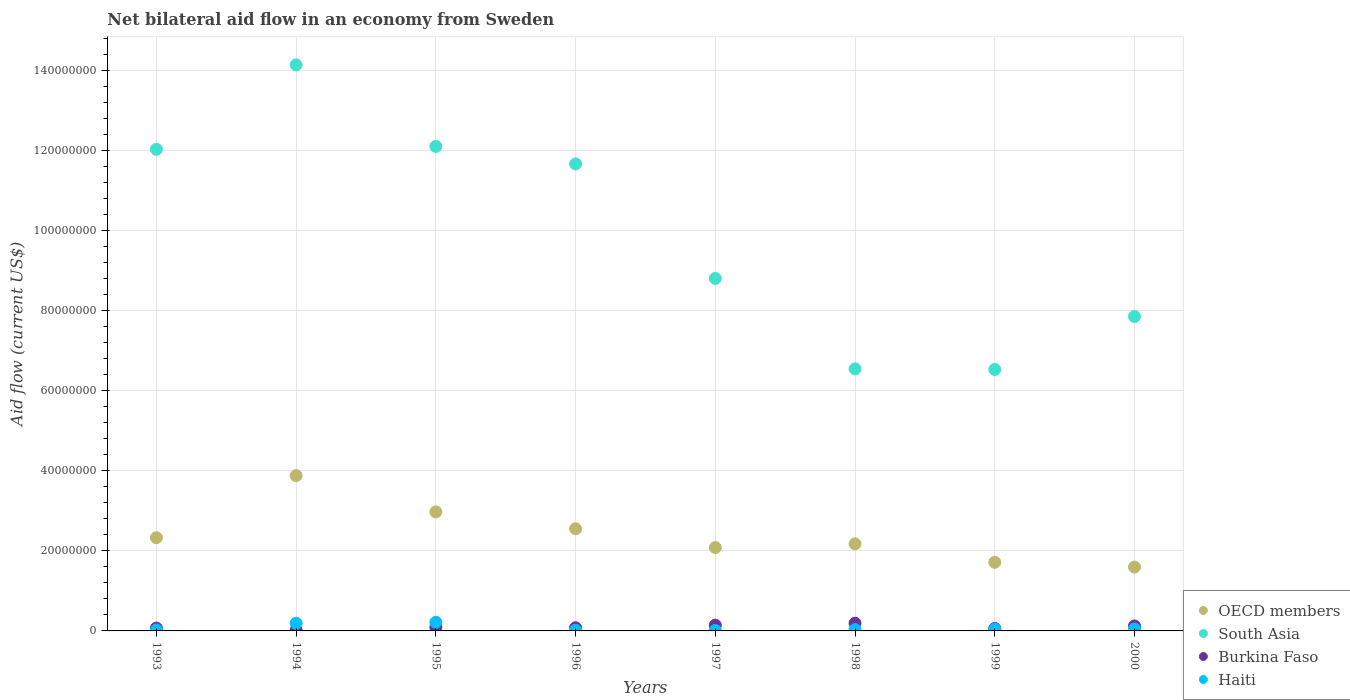How many different coloured dotlines are there?
Your answer should be very brief. 4. What is the net bilateral aid flow in South Asia in 1996?
Your answer should be compact. 1.17e+08. Across all years, what is the maximum net bilateral aid flow in Haiti?
Give a very brief answer. 2.16e+06. Across all years, what is the minimum net bilateral aid flow in Haiti?
Your response must be concise. 1.20e+05. In which year was the net bilateral aid flow in South Asia maximum?
Your answer should be very brief. 1994. What is the total net bilateral aid flow in OECD members in the graph?
Give a very brief answer. 1.93e+08. What is the difference between the net bilateral aid flow in Burkina Faso in 1993 and that in 1994?
Keep it short and to the point. 5.30e+05. What is the difference between the net bilateral aid flow in OECD members in 1998 and the net bilateral aid flow in South Asia in 1994?
Keep it short and to the point. -1.20e+08. What is the average net bilateral aid flow in Burkina Faso per year?
Give a very brief answer. 9.79e+05. In the year 1999, what is the difference between the net bilateral aid flow in South Asia and net bilateral aid flow in Burkina Faso?
Your answer should be compact. 6.47e+07. What is the ratio of the net bilateral aid flow in OECD members in 1998 to that in 2000?
Provide a succinct answer. 1.36. What is the difference between the highest and the second highest net bilateral aid flow in South Asia?
Offer a terse response. 2.04e+07. What is the difference between the highest and the lowest net bilateral aid flow in Burkina Faso?
Give a very brief answer. 1.75e+06. Is the sum of the net bilateral aid flow in OECD members in 1993 and 1996 greater than the maximum net bilateral aid flow in Burkina Faso across all years?
Your response must be concise. Yes. Is it the case that in every year, the sum of the net bilateral aid flow in South Asia and net bilateral aid flow in Burkina Faso  is greater than the sum of net bilateral aid flow in Haiti and net bilateral aid flow in OECD members?
Offer a terse response. Yes. Is the net bilateral aid flow in South Asia strictly greater than the net bilateral aid flow in Burkina Faso over the years?
Keep it short and to the point. Yes. How many dotlines are there?
Give a very brief answer. 4. What is the difference between two consecutive major ticks on the Y-axis?
Provide a succinct answer. 2.00e+07. Does the graph contain grids?
Give a very brief answer. Yes. Where does the legend appear in the graph?
Your response must be concise. Bottom right. How are the legend labels stacked?
Provide a short and direct response. Vertical. What is the title of the graph?
Your answer should be compact. Net bilateral aid flow in an economy from Sweden. Does "Brazil" appear as one of the legend labels in the graph?
Give a very brief answer. No. What is the Aid flow (current US$) of OECD members in 1993?
Your answer should be very brief. 2.33e+07. What is the Aid flow (current US$) of South Asia in 1993?
Ensure brevity in your answer.  1.20e+08. What is the Aid flow (current US$) in Burkina Faso in 1993?
Your answer should be very brief. 7.10e+05. What is the Aid flow (current US$) of OECD members in 1994?
Give a very brief answer. 3.88e+07. What is the Aid flow (current US$) in South Asia in 1994?
Make the answer very short. 1.41e+08. What is the Aid flow (current US$) in Haiti in 1994?
Make the answer very short. 1.90e+06. What is the Aid flow (current US$) in OECD members in 1995?
Give a very brief answer. 2.97e+07. What is the Aid flow (current US$) in South Asia in 1995?
Provide a short and direct response. 1.21e+08. What is the Aid flow (current US$) of Burkina Faso in 1995?
Your answer should be very brief. 9.10e+05. What is the Aid flow (current US$) in Haiti in 1995?
Your answer should be very brief. 2.16e+06. What is the Aid flow (current US$) of OECD members in 1996?
Your response must be concise. 2.55e+07. What is the Aid flow (current US$) of South Asia in 1996?
Your answer should be compact. 1.17e+08. What is the Aid flow (current US$) of Burkina Faso in 1996?
Give a very brief answer. 7.90e+05. What is the Aid flow (current US$) of OECD members in 1997?
Keep it short and to the point. 2.08e+07. What is the Aid flow (current US$) in South Asia in 1997?
Provide a succinct answer. 8.81e+07. What is the Aid flow (current US$) of Burkina Faso in 1997?
Your response must be concise. 1.44e+06. What is the Aid flow (current US$) in OECD members in 1998?
Offer a very short reply. 2.18e+07. What is the Aid flow (current US$) in South Asia in 1998?
Your response must be concise. 6.55e+07. What is the Aid flow (current US$) in Burkina Faso in 1998?
Keep it short and to the point. 1.93e+06. What is the Aid flow (current US$) in OECD members in 1999?
Your answer should be compact. 1.72e+07. What is the Aid flow (current US$) in South Asia in 1999?
Your response must be concise. 6.53e+07. What is the Aid flow (current US$) of Burkina Faso in 1999?
Your response must be concise. 6.30e+05. What is the Aid flow (current US$) of OECD members in 2000?
Offer a terse response. 1.60e+07. What is the Aid flow (current US$) of South Asia in 2000?
Provide a succinct answer. 7.86e+07. What is the Aid flow (current US$) in Burkina Faso in 2000?
Your answer should be compact. 1.24e+06. Across all years, what is the maximum Aid flow (current US$) of OECD members?
Provide a succinct answer. 3.88e+07. Across all years, what is the maximum Aid flow (current US$) of South Asia?
Keep it short and to the point. 1.41e+08. Across all years, what is the maximum Aid flow (current US$) in Burkina Faso?
Make the answer very short. 1.93e+06. Across all years, what is the maximum Aid flow (current US$) of Haiti?
Your response must be concise. 2.16e+06. Across all years, what is the minimum Aid flow (current US$) of OECD members?
Your response must be concise. 1.60e+07. Across all years, what is the minimum Aid flow (current US$) in South Asia?
Provide a short and direct response. 6.53e+07. What is the total Aid flow (current US$) of OECD members in the graph?
Ensure brevity in your answer.  1.93e+08. What is the total Aid flow (current US$) of South Asia in the graph?
Offer a very short reply. 7.97e+08. What is the total Aid flow (current US$) of Burkina Faso in the graph?
Make the answer very short. 7.83e+06. What is the total Aid flow (current US$) of Haiti in the graph?
Keep it short and to the point. 5.83e+06. What is the difference between the Aid flow (current US$) of OECD members in 1993 and that in 1994?
Keep it short and to the point. -1.55e+07. What is the difference between the Aid flow (current US$) of South Asia in 1993 and that in 1994?
Your answer should be very brief. -2.11e+07. What is the difference between the Aid flow (current US$) in Burkina Faso in 1993 and that in 1994?
Provide a succinct answer. 5.30e+05. What is the difference between the Aid flow (current US$) of Haiti in 1993 and that in 1994?
Keep it short and to the point. -1.68e+06. What is the difference between the Aid flow (current US$) of OECD members in 1993 and that in 1995?
Provide a succinct answer. -6.44e+06. What is the difference between the Aid flow (current US$) of South Asia in 1993 and that in 1995?
Ensure brevity in your answer.  -7.20e+05. What is the difference between the Aid flow (current US$) of Haiti in 1993 and that in 1995?
Your answer should be compact. -1.94e+06. What is the difference between the Aid flow (current US$) of OECD members in 1993 and that in 1996?
Offer a terse response. -2.23e+06. What is the difference between the Aid flow (current US$) in South Asia in 1993 and that in 1996?
Your answer should be compact. 3.65e+06. What is the difference between the Aid flow (current US$) of Haiti in 1993 and that in 1996?
Your answer should be very brief. 5.00e+04. What is the difference between the Aid flow (current US$) of OECD members in 1993 and that in 1997?
Provide a succinct answer. 2.46e+06. What is the difference between the Aid flow (current US$) of South Asia in 1993 and that in 1997?
Your answer should be very brief. 3.23e+07. What is the difference between the Aid flow (current US$) of Burkina Faso in 1993 and that in 1997?
Ensure brevity in your answer.  -7.30e+05. What is the difference between the Aid flow (current US$) in Haiti in 1993 and that in 1997?
Provide a succinct answer. 1.00e+05. What is the difference between the Aid flow (current US$) of OECD members in 1993 and that in 1998?
Make the answer very short. 1.54e+06. What is the difference between the Aid flow (current US$) of South Asia in 1993 and that in 1998?
Ensure brevity in your answer.  5.49e+07. What is the difference between the Aid flow (current US$) of Burkina Faso in 1993 and that in 1998?
Give a very brief answer. -1.22e+06. What is the difference between the Aid flow (current US$) in OECD members in 1993 and that in 1999?
Give a very brief answer. 6.15e+06. What is the difference between the Aid flow (current US$) of South Asia in 1993 and that in 1999?
Your response must be concise. 5.50e+07. What is the difference between the Aid flow (current US$) in OECD members in 1993 and that in 2000?
Your answer should be very brief. 7.34e+06. What is the difference between the Aid flow (current US$) of South Asia in 1993 and that in 2000?
Provide a succinct answer. 4.18e+07. What is the difference between the Aid flow (current US$) in Burkina Faso in 1993 and that in 2000?
Provide a succinct answer. -5.30e+05. What is the difference between the Aid flow (current US$) in Haiti in 1993 and that in 2000?
Offer a terse response. -2.70e+05. What is the difference between the Aid flow (current US$) of OECD members in 1994 and that in 1995?
Give a very brief answer. 9.07e+06. What is the difference between the Aid flow (current US$) in South Asia in 1994 and that in 1995?
Your response must be concise. 2.04e+07. What is the difference between the Aid flow (current US$) of Burkina Faso in 1994 and that in 1995?
Ensure brevity in your answer.  -7.30e+05. What is the difference between the Aid flow (current US$) of Haiti in 1994 and that in 1995?
Make the answer very short. -2.60e+05. What is the difference between the Aid flow (current US$) of OECD members in 1994 and that in 1996?
Offer a very short reply. 1.33e+07. What is the difference between the Aid flow (current US$) of South Asia in 1994 and that in 1996?
Provide a short and direct response. 2.48e+07. What is the difference between the Aid flow (current US$) in Burkina Faso in 1994 and that in 1996?
Keep it short and to the point. -6.10e+05. What is the difference between the Aid flow (current US$) of Haiti in 1994 and that in 1996?
Give a very brief answer. 1.73e+06. What is the difference between the Aid flow (current US$) in OECD members in 1994 and that in 1997?
Offer a terse response. 1.80e+07. What is the difference between the Aid flow (current US$) of South Asia in 1994 and that in 1997?
Offer a terse response. 5.34e+07. What is the difference between the Aid flow (current US$) in Burkina Faso in 1994 and that in 1997?
Provide a short and direct response. -1.26e+06. What is the difference between the Aid flow (current US$) in Haiti in 1994 and that in 1997?
Provide a succinct answer. 1.78e+06. What is the difference between the Aid flow (current US$) in OECD members in 1994 and that in 1998?
Ensure brevity in your answer.  1.70e+07. What is the difference between the Aid flow (current US$) of South Asia in 1994 and that in 1998?
Offer a very short reply. 7.60e+07. What is the difference between the Aid flow (current US$) of Burkina Faso in 1994 and that in 1998?
Your answer should be compact. -1.75e+06. What is the difference between the Aid flow (current US$) of Haiti in 1994 and that in 1998?
Offer a terse response. 1.58e+06. What is the difference between the Aid flow (current US$) of OECD members in 1994 and that in 1999?
Your answer should be very brief. 2.17e+07. What is the difference between the Aid flow (current US$) of South Asia in 1994 and that in 1999?
Provide a short and direct response. 7.61e+07. What is the difference between the Aid flow (current US$) of Burkina Faso in 1994 and that in 1999?
Keep it short and to the point. -4.50e+05. What is the difference between the Aid flow (current US$) in Haiti in 1994 and that in 1999?
Keep it short and to the point. 1.45e+06. What is the difference between the Aid flow (current US$) of OECD members in 1994 and that in 2000?
Ensure brevity in your answer.  2.28e+07. What is the difference between the Aid flow (current US$) in South Asia in 1994 and that in 2000?
Provide a short and direct response. 6.29e+07. What is the difference between the Aid flow (current US$) in Burkina Faso in 1994 and that in 2000?
Your response must be concise. -1.06e+06. What is the difference between the Aid flow (current US$) of Haiti in 1994 and that in 2000?
Provide a short and direct response. 1.41e+06. What is the difference between the Aid flow (current US$) in OECD members in 1995 and that in 1996?
Your response must be concise. 4.21e+06. What is the difference between the Aid flow (current US$) in South Asia in 1995 and that in 1996?
Provide a succinct answer. 4.37e+06. What is the difference between the Aid flow (current US$) of Burkina Faso in 1995 and that in 1996?
Ensure brevity in your answer.  1.20e+05. What is the difference between the Aid flow (current US$) of Haiti in 1995 and that in 1996?
Offer a very short reply. 1.99e+06. What is the difference between the Aid flow (current US$) of OECD members in 1995 and that in 1997?
Make the answer very short. 8.90e+06. What is the difference between the Aid flow (current US$) in South Asia in 1995 and that in 1997?
Make the answer very short. 3.30e+07. What is the difference between the Aid flow (current US$) in Burkina Faso in 1995 and that in 1997?
Provide a short and direct response. -5.30e+05. What is the difference between the Aid flow (current US$) in Haiti in 1995 and that in 1997?
Your response must be concise. 2.04e+06. What is the difference between the Aid flow (current US$) of OECD members in 1995 and that in 1998?
Offer a very short reply. 7.98e+06. What is the difference between the Aid flow (current US$) of South Asia in 1995 and that in 1998?
Make the answer very short. 5.56e+07. What is the difference between the Aid flow (current US$) of Burkina Faso in 1995 and that in 1998?
Offer a terse response. -1.02e+06. What is the difference between the Aid flow (current US$) of Haiti in 1995 and that in 1998?
Ensure brevity in your answer.  1.84e+06. What is the difference between the Aid flow (current US$) in OECD members in 1995 and that in 1999?
Your answer should be very brief. 1.26e+07. What is the difference between the Aid flow (current US$) of South Asia in 1995 and that in 1999?
Provide a succinct answer. 5.57e+07. What is the difference between the Aid flow (current US$) of Haiti in 1995 and that in 1999?
Ensure brevity in your answer.  1.71e+06. What is the difference between the Aid flow (current US$) of OECD members in 1995 and that in 2000?
Keep it short and to the point. 1.38e+07. What is the difference between the Aid flow (current US$) in South Asia in 1995 and that in 2000?
Keep it short and to the point. 4.25e+07. What is the difference between the Aid flow (current US$) in Burkina Faso in 1995 and that in 2000?
Offer a terse response. -3.30e+05. What is the difference between the Aid flow (current US$) of Haiti in 1995 and that in 2000?
Offer a very short reply. 1.67e+06. What is the difference between the Aid flow (current US$) in OECD members in 1996 and that in 1997?
Provide a succinct answer. 4.69e+06. What is the difference between the Aid flow (current US$) in South Asia in 1996 and that in 1997?
Provide a succinct answer. 2.86e+07. What is the difference between the Aid flow (current US$) in Burkina Faso in 1996 and that in 1997?
Ensure brevity in your answer.  -6.50e+05. What is the difference between the Aid flow (current US$) in OECD members in 1996 and that in 1998?
Your answer should be very brief. 3.77e+06. What is the difference between the Aid flow (current US$) in South Asia in 1996 and that in 1998?
Provide a succinct answer. 5.12e+07. What is the difference between the Aid flow (current US$) in Burkina Faso in 1996 and that in 1998?
Offer a terse response. -1.14e+06. What is the difference between the Aid flow (current US$) of OECD members in 1996 and that in 1999?
Your answer should be very brief. 8.38e+06. What is the difference between the Aid flow (current US$) in South Asia in 1996 and that in 1999?
Offer a terse response. 5.14e+07. What is the difference between the Aid flow (current US$) in Burkina Faso in 1996 and that in 1999?
Give a very brief answer. 1.60e+05. What is the difference between the Aid flow (current US$) of Haiti in 1996 and that in 1999?
Offer a very short reply. -2.80e+05. What is the difference between the Aid flow (current US$) in OECD members in 1996 and that in 2000?
Your answer should be compact. 9.57e+06. What is the difference between the Aid flow (current US$) in South Asia in 1996 and that in 2000?
Your response must be concise. 3.81e+07. What is the difference between the Aid flow (current US$) of Burkina Faso in 1996 and that in 2000?
Give a very brief answer. -4.50e+05. What is the difference between the Aid flow (current US$) of Haiti in 1996 and that in 2000?
Keep it short and to the point. -3.20e+05. What is the difference between the Aid flow (current US$) in OECD members in 1997 and that in 1998?
Offer a terse response. -9.20e+05. What is the difference between the Aid flow (current US$) of South Asia in 1997 and that in 1998?
Ensure brevity in your answer.  2.26e+07. What is the difference between the Aid flow (current US$) of Burkina Faso in 1997 and that in 1998?
Provide a short and direct response. -4.90e+05. What is the difference between the Aid flow (current US$) of Haiti in 1997 and that in 1998?
Provide a succinct answer. -2.00e+05. What is the difference between the Aid flow (current US$) of OECD members in 1997 and that in 1999?
Keep it short and to the point. 3.69e+06. What is the difference between the Aid flow (current US$) in South Asia in 1997 and that in 1999?
Provide a succinct answer. 2.28e+07. What is the difference between the Aid flow (current US$) of Burkina Faso in 1997 and that in 1999?
Give a very brief answer. 8.10e+05. What is the difference between the Aid flow (current US$) in Haiti in 1997 and that in 1999?
Offer a terse response. -3.30e+05. What is the difference between the Aid flow (current US$) in OECD members in 1997 and that in 2000?
Provide a succinct answer. 4.88e+06. What is the difference between the Aid flow (current US$) of South Asia in 1997 and that in 2000?
Ensure brevity in your answer.  9.51e+06. What is the difference between the Aid flow (current US$) of Haiti in 1997 and that in 2000?
Give a very brief answer. -3.70e+05. What is the difference between the Aid flow (current US$) of OECD members in 1998 and that in 1999?
Ensure brevity in your answer.  4.61e+06. What is the difference between the Aid flow (current US$) in Burkina Faso in 1998 and that in 1999?
Offer a very short reply. 1.30e+06. What is the difference between the Aid flow (current US$) of OECD members in 1998 and that in 2000?
Make the answer very short. 5.80e+06. What is the difference between the Aid flow (current US$) of South Asia in 1998 and that in 2000?
Keep it short and to the point. -1.31e+07. What is the difference between the Aid flow (current US$) in Burkina Faso in 1998 and that in 2000?
Your answer should be compact. 6.90e+05. What is the difference between the Aid flow (current US$) of Haiti in 1998 and that in 2000?
Provide a succinct answer. -1.70e+05. What is the difference between the Aid flow (current US$) of OECD members in 1999 and that in 2000?
Keep it short and to the point. 1.19e+06. What is the difference between the Aid flow (current US$) in South Asia in 1999 and that in 2000?
Ensure brevity in your answer.  -1.32e+07. What is the difference between the Aid flow (current US$) of Burkina Faso in 1999 and that in 2000?
Keep it short and to the point. -6.10e+05. What is the difference between the Aid flow (current US$) of Haiti in 1999 and that in 2000?
Ensure brevity in your answer.  -4.00e+04. What is the difference between the Aid flow (current US$) in OECD members in 1993 and the Aid flow (current US$) in South Asia in 1994?
Provide a succinct answer. -1.18e+08. What is the difference between the Aid flow (current US$) in OECD members in 1993 and the Aid flow (current US$) in Burkina Faso in 1994?
Offer a terse response. 2.31e+07. What is the difference between the Aid flow (current US$) in OECD members in 1993 and the Aid flow (current US$) in Haiti in 1994?
Provide a succinct answer. 2.14e+07. What is the difference between the Aid flow (current US$) in South Asia in 1993 and the Aid flow (current US$) in Burkina Faso in 1994?
Offer a very short reply. 1.20e+08. What is the difference between the Aid flow (current US$) in South Asia in 1993 and the Aid flow (current US$) in Haiti in 1994?
Your response must be concise. 1.18e+08. What is the difference between the Aid flow (current US$) in Burkina Faso in 1993 and the Aid flow (current US$) in Haiti in 1994?
Give a very brief answer. -1.19e+06. What is the difference between the Aid flow (current US$) in OECD members in 1993 and the Aid flow (current US$) in South Asia in 1995?
Your answer should be very brief. -9.78e+07. What is the difference between the Aid flow (current US$) in OECD members in 1993 and the Aid flow (current US$) in Burkina Faso in 1995?
Your answer should be compact. 2.24e+07. What is the difference between the Aid flow (current US$) of OECD members in 1993 and the Aid flow (current US$) of Haiti in 1995?
Give a very brief answer. 2.11e+07. What is the difference between the Aid flow (current US$) in South Asia in 1993 and the Aid flow (current US$) in Burkina Faso in 1995?
Your answer should be very brief. 1.19e+08. What is the difference between the Aid flow (current US$) in South Asia in 1993 and the Aid flow (current US$) in Haiti in 1995?
Ensure brevity in your answer.  1.18e+08. What is the difference between the Aid flow (current US$) in Burkina Faso in 1993 and the Aid flow (current US$) in Haiti in 1995?
Give a very brief answer. -1.45e+06. What is the difference between the Aid flow (current US$) in OECD members in 1993 and the Aid flow (current US$) in South Asia in 1996?
Your answer should be compact. -9.34e+07. What is the difference between the Aid flow (current US$) in OECD members in 1993 and the Aid flow (current US$) in Burkina Faso in 1996?
Your response must be concise. 2.25e+07. What is the difference between the Aid flow (current US$) in OECD members in 1993 and the Aid flow (current US$) in Haiti in 1996?
Your answer should be very brief. 2.31e+07. What is the difference between the Aid flow (current US$) in South Asia in 1993 and the Aid flow (current US$) in Burkina Faso in 1996?
Offer a very short reply. 1.20e+08. What is the difference between the Aid flow (current US$) in South Asia in 1993 and the Aid flow (current US$) in Haiti in 1996?
Keep it short and to the point. 1.20e+08. What is the difference between the Aid flow (current US$) in Burkina Faso in 1993 and the Aid flow (current US$) in Haiti in 1996?
Give a very brief answer. 5.40e+05. What is the difference between the Aid flow (current US$) in OECD members in 1993 and the Aid flow (current US$) in South Asia in 1997?
Your answer should be very brief. -6.48e+07. What is the difference between the Aid flow (current US$) of OECD members in 1993 and the Aid flow (current US$) of Burkina Faso in 1997?
Provide a short and direct response. 2.19e+07. What is the difference between the Aid flow (current US$) in OECD members in 1993 and the Aid flow (current US$) in Haiti in 1997?
Your answer should be very brief. 2.32e+07. What is the difference between the Aid flow (current US$) in South Asia in 1993 and the Aid flow (current US$) in Burkina Faso in 1997?
Offer a terse response. 1.19e+08. What is the difference between the Aid flow (current US$) of South Asia in 1993 and the Aid flow (current US$) of Haiti in 1997?
Provide a succinct answer. 1.20e+08. What is the difference between the Aid flow (current US$) of Burkina Faso in 1993 and the Aid flow (current US$) of Haiti in 1997?
Give a very brief answer. 5.90e+05. What is the difference between the Aid flow (current US$) of OECD members in 1993 and the Aid flow (current US$) of South Asia in 1998?
Offer a terse response. -4.22e+07. What is the difference between the Aid flow (current US$) in OECD members in 1993 and the Aid flow (current US$) in Burkina Faso in 1998?
Ensure brevity in your answer.  2.14e+07. What is the difference between the Aid flow (current US$) in OECD members in 1993 and the Aid flow (current US$) in Haiti in 1998?
Keep it short and to the point. 2.30e+07. What is the difference between the Aid flow (current US$) of South Asia in 1993 and the Aid flow (current US$) of Burkina Faso in 1998?
Offer a very short reply. 1.18e+08. What is the difference between the Aid flow (current US$) of South Asia in 1993 and the Aid flow (current US$) of Haiti in 1998?
Keep it short and to the point. 1.20e+08. What is the difference between the Aid flow (current US$) in Burkina Faso in 1993 and the Aid flow (current US$) in Haiti in 1998?
Make the answer very short. 3.90e+05. What is the difference between the Aid flow (current US$) in OECD members in 1993 and the Aid flow (current US$) in South Asia in 1999?
Your response must be concise. -4.20e+07. What is the difference between the Aid flow (current US$) in OECD members in 1993 and the Aid flow (current US$) in Burkina Faso in 1999?
Provide a short and direct response. 2.27e+07. What is the difference between the Aid flow (current US$) of OECD members in 1993 and the Aid flow (current US$) of Haiti in 1999?
Provide a short and direct response. 2.28e+07. What is the difference between the Aid flow (current US$) of South Asia in 1993 and the Aid flow (current US$) of Burkina Faso in 1999?
Your answer should be very brief. 1.20e+08. What is the difference between the Aid flow (current US$) in South Asia in 1993 and the Aid flow (current US$) in Haiti in 1999?
Offer a very short reply. 1.20e+08. What is the difference between the Aid flow (current US$) in OECD members in 1993 and the Aid flow (current US$) in South Asia in 2000?
Your response must be concise. -5.53e+07. What is the difference between the Aid flow (current US$) of OECD members in 1993 and the Aid flow (current US$) of Burkina Faso in 2000?
Keep it short and to the point. 2.21e+07. What is the difference between the Aid flow (current US$) of OECD members in 1993 and the Aid flow (current US$) of Haiti in 2000?
Provide a succinct answer. 2.28e+07. What is the difference between the Aid flow (current US$) of South Asia in 1993 and the Aid flow (current US$) of Burkina Faso in 2000?
Give a very brief answer. 1.19e+08. What is the difference between the Aid flow (current US$) in South Asia in 1993 and the Aid flow (current US$) in Haiti in 2000?
Offer a terse response. 1.20e+08. What is the difference between the Aid flow (current US$) of OECD members in 1994 and the Aid flow (current US$) of South Asia in 1995?
Offer a very short reply. -8.23e+07. What is the difference between the Aid flow (current US$) in OECD members in 1994 and the Aid flow (current US$) in Burkina Faso in 1995?
Give a very brief answer. 3.79e+07. What is the difference between the Aid flow (current US$) of OECD members in 1994 and the Aid flow (current US$) of Haiti in 1995?
Offer a very short reply. 3.66e+07. What is the difference between the Aid flow (current US$) in South Asia in 1994 and the Aid flow (current US$) in Burkina Faso in 1995?
Ensure brevity in your answer.  1.41e+08. What is the difference between the Aid flow (current US$) of South Asia in 1994 and the Aid flow (current US$) of Haiti in 1995?
Keep it short and to the point. 1.39e+08. What is the difference between the Aid flow (current US$) of Burkina Faso in 1994 and the Aid flow (current US$) of Haiti in 1995?
Keep it short and to the point. -1.98e+06. What is the difference between the Aid flow (current US$) of OECD members in 1994 and the Aid flow (current US$) of South Asia in 1996?
Keep it short and to the point. -7.79e+07. What is the difference between the Aid flow (current US$) of OECD members in 1994 and the Aid flow (current US$) of Burkina Faso in 1996?
Provide a short and direct response. 3.80e+07. What is the difference between the Aid flow (current US$) of OECD members in 1994 and the Aid flow (current US$) of Haiti in 1996?
Offer a very short reply. 3.86e+07. What is the difference between the Aid flow (current US$) in South Asia in 1994 and the Aid flow (current US$) in Burkina Faso in 1996?
Your response must be concise. 1.41e+08. What is the difference between the Aid flow (current US$) in South Asia in 1994 and the Aid flow (current US$) in Haiti in 1996?
Your answer should be very brief. 1.41e+08. What is the difference between the Aid flow (current US$) of OECD members in 1994 and the Aid flow (current US$) of South Asia in 1997?
Offer a very short reply. -4.93e+07. What is the difference between the Aid flow (current US$) of OECD members in 1994 and the Aid flow (current US$) of Burkina Faso in 1997?
Provide a short and direct response. 3.74e+07. What is the difference between the Aid flow (current US$) of OECD members in 1994 and the Aid flow (current US$) of Haiti in 1997?
Offer a terse response. 3.87e+07. What is the difference between the Aid flow (current US$) in South Asia in 1994 and the Aid flow (current US$) in Burkina Faso in 1997?
Make the answer very short. 1.40e+08. What is the difference between the Aid flow (current US$) in South Asia in 1994 and the Aid flow (current US$) in Haiti in 1997?
Offer a very short reply. 1.41e+08. What is the difference between the Aid flow (current US$) of Burkina Faso in 1994 and the Aid flow (current US$) of Haiti in 1997?
Your answer should be very brief. 6.00e+04. What is the difference between the Aid flow (current US$) in OECD members in 1994 and the Aid flow (current US$) in South Asia in 1998?
Offer a terse response. -2.67e+07. What is the difference between the Aid flow (current US$) in OECD members in 1994 and the Aid flow (current US$) in Burkina Faso in 1998?
Offer a very short reply. 3.69e+07. What is the difference between the Aid flow (current US$) of OECD members in 1994 and the Aid flow (current US$) of Haiti in 1998?
Offer a very short reply. 3.85e+07. What is the difference between the Aid flow (current US$) of South Asia in 1994 and the Aid flow (current US$) of Burkina Faso in 1998?
Provide a succinct answer. 1.40e+08. What is the difference between the Aid flow (current US$) of South Asia in 1994 and the Aid flow (current US$) of Haiti in 1998?
Offer a terse response. 1.41e+08. What is the difference between the Aid flow (current US$) of OECD members in 1994 and the Aid flow (current US$) of South Asia in 1999?
Your response must be concise. -2.65e+07. What is the difference between the Aid flow (current US$) in OECD members in 1994 and the Aid flow (current US$) in Burkina Faso in 1999?
Your answer should be very brief. 3.82e+07. What is the difference between the Aid flow (current US$) of OECD members in 1994 and the Aid flow (current US$) of Haiti in 1999?
Your answer should be compact. 3.84e+07. What is the difference between the Aid flow (current US$) of South Asia in 1994 and the Aid flow (current US$) of Burkina Faso in 1999?
Provide a short and direct response. 1.41e+08. What is the difference between the Aid flow (current US$) of South Asia in 1994 and the Aid flow (current US$) of Haiti in 1999?
Provide a short and direct response. 1.41e+08. What is the difference between the Aid flow (current US$) of Burkina Faso in 1994 and the Aid flow (current US$) of Haiti in 1999?
Provide a short and direct response. -2.70e+05. What is the difference between the Aid flow (current US$) in OECD members in 1994 and the Aid flow (current US$) in South Asia in 2000?
Your answer should be compact. -3.98e+07. What is the difference between the Aid flow (current US$) in OECD members in 1994 and the Aid flow (current US$) in Burkina Faso in 2000?
Offer a terse response. 3.76e+07. What is the difference between the Aid flow (current US$) of OECD members in 1994 and the Aid flow (current US$) of Haiti in 2000?
Provide a succinct answer. 3.83e+07. What is the difference between the Aid flow (current US$) in South Asia in 1994 and the Aid flow (current US$) in Burkina Faso in 2000?
Keep it short and to the point. 1.40e+08. What is the difference between the Aid flow (current US$) of South Asia in 1994 and the Aid flow (current US$) of Haiti in 2000?
Your response must be concise. 1.41e+08. What is the difference between the Aid flow (current US$) of Burkina Faso in 1994 and the Aid flow (current US$) of Haiti in 2000?
Your answer should be very brief. -3.10e+05. What is the difference between the Aid flow (current US$) of OECD members in 1995 and the Aid flow (current US$) of South Asia in 1996?
Provide a succinct answer. -8.70e+07. What is the difference between the Aid flow (current US$) of OECD members in 1995 and the Aid flow (current US$) of Burkina Faso in 1996?
Make the answer very short. 2.90e+07. What is the difference between the Aid flow (current US$) of OECD members in 1995 and the Aid flow (current US$) of Haiti in 1996?
Ensure brevity in your answer.  2.96e+07. What is the difference between the Aid flow (current US$) of South Asia in 1995 and the Aid flow (current US$) of Burkina Faso in 1996?
Ensure brevity in your answer.  1.20e+08. What is the difference between the Aid flow (current US$) in South Asia in 1995 and the Aid flow (current US$) in Haiti in 1996?
Give a very brief answer. 1.21e+08. What is the difference between the Aid flow (current US$) of Burkina Faso in 1995 and the Aid flow (current US$) of Haiti in 1996?
Provide a succinct answer. 7.40e+05. What is the difference between the Aid flow (current US$) in OECD members in 1995 and the Aid flow (current US$) in South Asia in 1997?
Provide a succinct answer. -5.83e+07. What is the difference between the Aid flow (current US$) of OECD members in 1995 and the Aid flow (current US$) of Burkina Faso in 1997?
Your answer should be very brief. 2.83e+07. What is the difference between the Aid flow (current US$) of OECD members in 1995 and the Aid flow (current US$) of Haiti in 1997?
Ensure brevity in your answer.  2.96e+07. What is the difference between the Aid flow (current US$) of South Asia in 1995 and the Aid flow (current US$) of Burkina Faso in 1997?
Provide a succinct answer. 1.20e+08. What is the difference between the Aid flow (current US$) in South Asia in 1995 and the Aid flow (current US$) in Haiti in 1997?
Ensure brevity in your answer.  1.21e+08. What is the difference between the Aid flow (current US$) in Burkina Faso in 1995 and the Aid flow (current US$) in Haiti in 1997?
Offer a terse response. 7.90e+05. What is the difference between the Aid flow (current US$) in OECD members in 1995 and the Aid flow (current US$) in South Asia in 1998?
Offer a terse response. -3.57e+07. What is the difference between the Aid flow (current US$) of OECD members in 1995 and the Aid flow (current US$) of Burkina Faso in 1998?
Offer a very short reply. 2.78e+07. What is the difference between the Aid flow (current US$) of OECD members in 1995 and the Aid flow (current US$) of Haiti in 1998?
Give a very brief answer. 2.94e+07. What is the difference between the Aid flow (current US$) of South Asia in 1995 and the Aid flow (current US$) of Burkina Faso in 1998?
Ensure brevity in your answer.  1.19e+08. What is the difference between the Aid flow (current US$) of South Asia in 1995 and the Aid flow (current US$) of Haiti in 1998?
Offer a very short reply. 1.21e+08. What is the difference between the Aid flow (current US$) in Burkina Faso in 1995 and the Aid flow (current US$) in Haiti in 1998?
Make the answer very short. 5.90e+05. What is the difference between the Aid flow (current US$) in OECD members in 1995 and the Aid flow (current US$) in South Asia in 1999?
Provide a succinct answer. -3.56e+07. What is the difference between the Aid flow (current US$) of OECD members in 1995 and the Aid flow (current US$) of Burkina Faso in 1999?
Give a very brief answer. 2.91e+07. What is the difference between the Aid flow (current US$) of OECD members in 1995 and the Aid flow (current US$) of Haiti in 1999?
Keep it short and to the point. 2.93e+07. What is the difference between the Aid flow (current US$) in South Asia in 1995 and the Aid flow (current US$) in Burkina Faso in 1999?
Provide a succinct answer. 1.20e+08. What is the difference between the Aid flow (current US$) in South Asia in 1995 and the Aid flow (current US$) in Haiti in 1999?
Make the answer very short. 1.21e+08. What is the difference between the Aid flow (current US$) of Burkina Faso in 1995 and the Aid flow (current US$) of Haiti in 1999?
Give a very brief answer. 4.60e+05. What is the difference between the Aid flow (current US$) of OECD members in 1995 and the Aid flow (current US$) of South Asia in 2000?
Offer a terse response. -4.88e+07. What is the difference between the Aid flow (current US$) in OECD members in 1995 and the Aid flow (current US$) in Burkina Faso in 2000?
Offer a terse response. 2.85e+07. What is the difference between the Aid flow (current US$) of OECD members in 1995 and the Aid flow (current US$) of Haiti in 2000?
Ensure brevity in your answer.  2.92e+07. What is the difference between the Aid flow (current US$) of South Asia in 1995 and the Aid flow (current US$) of Burkina Faso in 2000?
Make the answer very short. 1.20e+08. What is the difference between the Aid flow (current US$) of South Asia in 1995 and the Aid flow (current US$) of Haiti in 2000?
Make the answer very short. 1.21e+08. What is the difference between the Aid flow (current US$) of Burkina Faso in 1995 and the Aid flow (current US$) of Haiti in 2000?
Keep it short and to the point. 4.20e+05. What is the difference between the Aid flow (current US$) in OECD members in 1996 and the Aid flow (current US$) in South Asia in 1997?
Provide a short and direct response. -6.26e+07. What is the difference between the Aid flow (current US$) of OECD members in 1996 and the Aid flow (current US$) of Burkina Faso in 1997?
Offer a terse response. 2.41e+07. What is the difference between the Aid flow (current US$) of OECD members in 1996 and the Aid flow (current US$) of Haiti in 1997?
Provide a succinct answer. 2.54e+07. What is the difference between the Aid flow (current US$) of South Asia in 1996 and the Aid flow (current US$) of Burkina Faso in 1997?
Provide a succinct answer. 1.15e+08. What is the difference between the Aid flow (current US$) of South Asia in 1996 and the Aid flow (current US$) of Haiti in 1997?
Offer a very short reply. 1.17e+08. What is the difference between the Aid flow (current US$) of Burkina Faso in 1996 and the Aid flow (current US$) of Haiti in 1997?
Your response must be concise. 6.70e+05. What is the difference between the Aid flow (current US$) of OECD members in 1996 and the Aid flow (current US$) of South Asia in 1998?
Your answer should be compact. -3.99e+07. What is the difference between the Aid flow (current US$) in OECD members in 1996 and the Aid flow (current US$) in Burkina Faso in 1998?
Offer a terse response. 2.36e+07. What is the difference between the Aid flow (current US$) in OECD members in 1996 and the Aid flow (current US$) in Haiti in 1998?
Give a very brief answer. 2.52e+07. What is the difference between the Aid flow (current US$) of South Asia in 1996 and the Aid flow (current US$) of Burkina Faso in 1998?
Provide a short and direct response. 1.15e+08. What is the difference between the Aid flow (current US$) in South Asia in 1996 and the Aid flow (current US$) in Haiti in 1998?
Offer a very short reply. 1.16e+08. What is the difference between the Aid flow (current US$) of Burkina Faso in 1996 and the Aid flow (current US$) of Haiti in 1998?
Offer a terse response. 4.70e+05. What is the difference between the Aid flow (current US$) in OECD members in 1996 and the Aid flow (current US$) in South Asia in 1999?
Provide a succinct answer. -3.98e+07. What is the difference between the Aid flow (current US$) of OECD members in 1996 and the Aid flow (current US$) of Burkina Faso in 1999?
Offer a terse response. 2.49e+07. What is the difference between the Aid flow (current US$) of OECD members in 1996 and the Aid flow (current US$) of Haiti in 1999?
Your answer should be compact. 2.51e+07. What is the difference between the Aid flow (current US$) of South Asia in 1996 and the Aid flow (current US$) of Burkina Faso in 1999?
Your response must be concise. 1.16e+08. What is the difference between the Aid flow (current US$) in South Asia in 1996 and the Aid flow (current US$) in Haiti in 1999?
Your response must be concise. 1.16e+08. What is the difference between the Aid flow (current US$) of OECD members in 1996 and the Aid flow (current US$) of South Asia in 2000?
Offer a very short reply. -5.30e+07. What is the difference between the Aid flow (current US$) in OECD members in 1996 and the Aid flow (current US$) in Burkina Faso in 2000?
Offer a very short reply. 2.43e+07. What is the difference between the Aid flow (current US$) in OECD members in 1996 and the Aid flow (current US$) in Haiti in 2000?
Offer a terse response. 2.50e+07. What is the difference between the Aid flow (current US$) in South Asia in 1996 and the Aid flow (current US$) in Burkina Faso in 2000?
Ensure brevity in your answer.  1.15e+08. What is the difference between the Aid flow (current US$) of South Asia in 1996 and the Aid flow (current US$) of Haiti in 2000?
Provide a succinct answer. 1.16e+08. What is the difference between the Aid flow (current US$) of OECD members in 1997 and the Aid flow (current US$) of South Asia in 1998?
Provide a short and direct response. -4.46e+07. What is the difference between the Aid flow (current US$) in OECD members in 1997 and the Aid flow (current US$) in Burkina Faso in 1998?
Ensure brevity in your answer.  1.89e+07. What is the difference between the Aid flow (current US$) of OECD members in 1997 and the Aid flow (current US$) of Haiti in 1998?
Your response must be concise. 2.05e+07. What is the difference between the Aid flow (current US$) of South Asia in 1997 and the Aid flow (current US$) of Burkina Faso in 1998?
Your response must be concise. 8.62e+07. What is the difference between the Aid flow (current US$) of South Asia in 1997 and the Aid flow (current US$) of Haiti in 1998?
Keep it short and to the point. 8.78e+07. What is the difference between the Aid flow (current US$) in Burkina Faso in 1997 and the Aid flow (current US$) in Haiti in 1998?
Provide a short and direct response. 1.12e+06. What is the difference between the Aid flow (current US$) in OECD members in 1997 and the Aid flow (current US$) in South Asia in 1999?
Give a very brief answer. -4.45e+07. What is the difference between the Aid flow (current US$) in OECD members in 1997 and the Aid flow (current US$) in Burkina Faso in 1999?
Make the answer very short. 2.02e+07. What is the difference between the Aid flow (current US$) in OECD members in 1997 and the Aid flow (current US$) in Haiti in 1999?
Offer a terse response. 2.04e+07. What is the difference between the Aid flow (current US$) in South Asia in 1997 and the Aid flow (current US$) in Burkina Faso in 1999?
Your response must be concise. 8.74e+07. What is the difference between the Aid flow (current US$) of South Asia in 1997 and the Aid flow (current US$) of Haiti in 1999?
Ensure brevity in your answer.  8.76e+07. What is the difference between the Aid flow (current US$) of Burkina Faso in 1997 and the Aid flow (current US$) of Haiti in 1999?
Make the answer very short. 9.90e+05. What is the difference between the Aid flow (current US$) of OECD members in 1997 and the Aid flow (current US$) of South Asia in 2000?
Your answer should be very brief. -5.77e+07. What is the difference between the Aid flow (current US$) in OECD members in 1997 and the Aid flow (current US$) in Burkina Faso in 2000?
Your answer should be compact. 1.96e+07. What is the difference between the Aid flow (current US$) in OECD members in 1997 and the Aid flow (current US$) in Haiti in 2000?
Offer a terse response. 2.04e+07. What is the difference between the Aid flow (current US$) in South Asia in 1997 and the Aid flow (current US$) in Burkina Faso in 2000?
Make the answer very short. 8.68e+07. What is the difference between the Aid flow (current US$) in South Asia in 1997 and the Aid flow (current US$) in Haiti in 2000?
Offer a terse response. 8.76e+07. What is the difference between the Aid flow (current US$) in Burkina Faso in 1997 and the Aid flow (current US$) in Haiti in 2000?
Offer a terse response. 9.50e+05. What is the difference between the Aid flow (current US$) of OECD members in 1998 and the Aid flow (current US$) of South Asia in 1999?
Your response must be concise. -4.36e+07. What is the difference between the Aid flow (current US$) of OECD members in 1998 and the Aid flow (current US$) of Burkina Faso in 1999?
Make the answer very short. 2.11e+07. What is the difference between the Aid flow (current US$) in OECD members in 1998 and the Aid flow (current US$) in Haiti in 1999?
Your answer should be very brief. 2.13e+07. What is the difference between the Aid flow (current US$) of South Asia in 1998 and the Aid flow (current US$) of Burkina Faso in 1999?
Make the answer very short. 6.48e+07. What is the difference between the Aid flow (current US$) in South Asia in 1998 and the Aid flow (current US$) in Haiti in 1999?
Make the answer very short. 6.50e+07. What is the difference between the Aid flow (current US$) of Burkina Faso in 1998 and the Aid flow (current US$) of Haiti in 1999?
Offer a very short reply. 1.48e+06. What is the difference between the Aid flow (current US$) in OECD members in 1998 and the Aid flow (current US$) in South Asia in 2000?
Offer a terse response. -5.68e+07. What is the difference between the Aid flow (current US$) in OECD members in 1998 and the Aid flow (current US$) in Burkina Faso in 2000?
Make the answer very short. 2.05e+07. What is the difference between the Aid flow (current US$) of OECD members in 1998 and the Aid flow (current US$) of Haiti in 2000?
Give a very brief answer. 2.13e+07. What is the difference between the Aid flow (current US$) in South Asia in 1998 and the Aid flow (current US$) in Burkina Faso in 2000?
Your answer should be very brief. 6.42e+07. What is the difference between the Aid flow (current US$) in South Asia in 1998 and the Aid flow (current US$) in Haiti in 2000?
Your answer should be compact. 6.50e+07. What is the difference between the Aid flow (current US$) in Burkina Faso in 1998 and the Aid flow (current US$) in Haiti in 2000?
Offer a terse response. 1.44e+06. What is the difference between the Aid flow (current US$) in OECD members in 1999 and the Aid flow (current US$) in South Asia in 2000?
Your answer should be very brief. -6.14e+07. What is the difference between the Aid flow (current US$) of OECD members in 1999 and the Aid flow (current US$) of Burkina Faso in 2000?
Provide a succinct answer. 1.59e+07. What is the difference between the Aid flow (current US$) of OECD members in 1999 and the Aid flow (current US$) of Haiti in 2000?
Your answer should be very brief. 1.67e+07. What is the difference between the Aid flow (current US$) of South Asia in 1999 and the Aid flow (current US$) of Burkina Faso in 2000?
Provide a short and direct response. 6.41e+07. What is the difference between the Aid flow (current US$) in South Asia in 1999 and the Aid flow (current US$) in Haiti in 2000?
Offer a very short reply. 6.48e+07. What is the difference between the Aid flow (current US$) of Burkina Faso in 1999 and the Aid flow (current US$) of Haiti in 2000?
Ensure brevity in your answer.  1.40e+05. What is the average Aid flow (current US$) in OECD members per year?
Keep it short and to the point. 2.41e+07. What is the average Aid flow (current US$) of South Asia per year?
Offer a terse response. 9.96e+07. What is the average Aid flow (current US$) of Burkina Faso per year?
Your response must be concise. 9.79e+05. What is the average Aid flow (current US$) of Haiti per year?
Ensure brevity in your answer.  7.29e+05. In the year 1993, what is the difference between the Aid flow (current US$) in OECD members and Aid flow (current US$) in South Asia?
Provide a succinct answer. -9.70e+07. In the year 1993, what is the difference between the Aid flow (current US$) of OECD members and Aid flow (current US$) of Burkina Faso?
Give a very brief answer. 2.26e+07. In the year 1993, what is the difference between the Aid flow (current US$) of OECD members and Aid flow (current US$) of Haiti?
Provide a succinct answer. 2.31e+07. In the year 1993, what is the difference between the Aid flow (current US$) of South Asia and Aid flow (current US$) of Burkina Faso?
Your answer should be compact. 1.20e+08. In the year 1993, what is the difference between the Aid flow (current US$) of South Asia and Aid flow (current US$) of Haiti?
Keep it short and to the point. 1.20e+08. In the year 1993, what is the difference between the Aid flow (current US$) of Burkina Faso and Aid flow (current US$) of Haiti?
Keep it short and to the point. 4.90e+05. In the year 1994, what is the difference between the Aid flow (current US$) of OECD members and Aid flow (current US$) of South Asia?
Your response must be concise. -1.03e+08. In the year 1994, what is the difference between the Aid flow (current US$) of OECD members and Aid flow (current US$) of Burkina Faso?
Your response must be concise. 3.86e+07. In the year 1994, what is the difference between the Aid flow (current US$) of OECD members and Aid flow (current US$) of Haiti?
Provide a short and direct response. 3.69e+07. In the year 1994, what is the difference between the Aid flow (current US$) of South Asia and Aid flow (current US$) of Burkina Faso?
Keep it short and to the point. 1.41e+08. In the year 1994, what is the difference between the Aid flow (current US$) in South Asia and Aid flow (current US$) in Haiti?
Your answer should be very brief. 1.40e+08. In the year 1994, what is the difference between the Aid flow (current US$) of Burkina Faso and Aid flow (current US$) of Haiti?
Your answer should be compact. -1.72e+06. In the year 1995, what is the difference between the Aid flow (current US$) of OECD members and Aid flow (current US$) of South Asia?
Your response must be concise. -9.13e+07. In the year 1995, what is the difference between the Aid flow (current US$) in OECD members and Aid flow (current US$) in Burkina Faso?
Your response must be concise. 2.88e+07. In the year 1995, what is the difference between the Aid flow (current US$) of OECD members and Aid flow (current US$) of Haiti?
Offer a terse response. 2.76e+07. In the year 1995, what is the difference between the Aid flow (current US$) of South Asia and Aid flow (current US$) of Burkina Faso?
Give a very brief answer. 1.20e+08. In the year 1995, what is the difference between the Aid flow (current US$) in South Asia and Aid flow (current US$) in Haiti?
Keep it short and to the point. 1.19e+08. In the year 1995, what is the difference between the Aid flow (current US$) in Burkina Faso and Aid flow (current US$) in Haiti?
Offer a terse response. -1.25e+06. In the year 1996, what is the difference between the Aid flow (current US$) of OECD members and Aid flow (current US$) of South Asia?
Provide a succinct answer. -9.12e+07. In the year 1996, what is the difference between the Aid flow (current US$) of OECD members and Aid flow (current US$) of Burkina Faso?
Give a very brief answer. 2.47e+07. In the year 1996, what is the difference between the Aid flow (current US$) of OECD members and Aid flow (current US$) of Haiti?
Make the answer very short. 2.54e+07. In the year 1996, what is the difference between the Aid flow (current US$) of South Asia and Aid flow (current US$) of Burkina Faso?
Keep it short and to the point. 1.16e+08. In the year 1996, what is the difference between the Aid flow (current US$) of South Asia and Aid flow (current US$) of Haiti?
Offer a very short reply. 1.17e+08. In the year 1996, what is the difference between the Aid flow (current US$) in Burkina Faso and Aid flow (current US$) in Haiti?
Your answer should be compact. 6.20e+05. In the year 1997, what is the difference between the Aid flow (current US$) of OECD members and Aid flow (current US$) of South Asia?
Your answer should be very brief. -6.72e+07. In the year 1997, what is the difference between the Aid flow (current US$) of OECD members and Aid flow (current US$) of Burkina Faso?
Give a very brief answer. 1.94e+07. In the year 1997, what is the difference between the Aid flow (current US$) of OECD members and Aid flow (current US$) of Haiti?
Your answer should be compact. 2.07e+07. In the year 1997, what is the difference between the Aid flow (current US$) of South Asia and Aid flow (current US$) of Burkina Faso?
Provide a short and direct response. 8.66e+07. In the year 1997, what is the difference between the Aid flow (current US$) in South Asia and Aid flow (current US$) in Haiti?
Ensure brevity in your answer.  8.80e+07. In the year 1997, what is the difference between the Aid flow (current US$) of Burkina Faso and Aid flow (current US$) of Haiti?
Offer a very short reply. 1.32e+06. In the year 1998, what is the difference between the Aid flow (current US$) in OECD members and Aid flow (current US$) in South Asia?
Provide a short and direct response. -4.37e+07. In the year 1998, what is the difference between the Aid flow (current US$) in OECD members and Aid flow (current US$) in Burkina Faso?
Offer a very short reply. 1.98e+07. In the year 1998, what is the difference between the Aid flow (current US$) of OECD members and Aid flow (current US$) of Haiti?
Offer a terse response. 2.14e+07. In the year 1998, what is the difference between the Aid flow (current US$) in South Asia and Aid flow (current US$) in Burkina Faso?
Keep it short and to the point. 6.35e+07. In the year 1998, what is the difference between the Aid flow (current US$) in South Asia and Aid flow (current US$) in Haiti?
Keep it short and to the point. 6.52e+07. In the year 1998, what is the difference between the Aid flow (current US$) of Burkina Faso and Aid flow (current US$) of Haiti?
Offer a very short reply. 1.61e+06. In the year 1999, what is the difference between the Aid flow (current US$) of OECD members and Aid flow (current US$) of South Asia?
Offer a terse response. -4.82e+07. In the year 1999, what is the difference between the Aid flow (current US$) in OECD members and Aid flow (current US$) in Burkina Faso?
Give a very brief answer. 1.65e+07. In the year 1999, what is the difference between the Aid flow (current US$) of OECD members and Aid flow (current US$) of Haiti?
Your response must be concise. 1.67e+07. In the year 1999, what is the difference between the Aid flow (current US$) in South Asia and Aid flow (current US$) in Burkina Faso?
Ensure brevity in your answer.  6.47e+07. In the year 1999, what is the difference between the Aid flow (current US$) in South Asia and Aid flow (current US$) in Haiti?
Give a very brief answer. 6.49e+07. In the year 2000, what is the difference between the Aid flow (current US$) of OECD members and Aid flow (current US$) of South Asia?
Offer a very short reply. -6.26e+07. In the year 2000, what is the difference between the Aid flow (current US$) of OECD members and Aid flow (current US$) of Burkina Faso?
Make the answer very short. 1.47e+07. In the year 2000, what is the difference between the Aid flow (current US$) in OECD members and Aid flow (current US$) in Haiti?
Provide a short and direct response. 1.55e+07. In the year 2000, what is the difference between the Aid flow (current US$) in South Asia and Aid flow (current US$) in Burkina Faso?
Ensure brevity in your answer.  7.73e+07. In the year 2000, what is the difference between the Aid flow (current US$) in South Asia and Aid flow (current US$) in Haiti?
Offer a very short reply. 7.81e+07. In the year 2000, what is the difference between the Aid flow (current US$) in Burkina Faso and Aid flow (current US$) in Haiti?
Give a very brief answer. 7.50e+05. What is the ratio of the Aid flow (current US$) in OECD members in 1993 to that in 1994?
Provide a short and direct response. 0.6. What is the ratio of the Aid flow (current US$) in South Asia in 1993 to that in 1994?
Provide a short and direct response. 0.85. What is the ratio of the Aid flow (current US$) of Burkina Faso in 1993 to that in 1994?
Offer a terse response. 3.94. What is the ratio of the Aid flow (current US$) of Haiti in 1993 to that in 1994?
Give a very brief answer. 0.12. What is the ratio of the Aid flow (current US$) of OECD members in 1993 to that in 1995?
Your response must be concise. 0.78. What is the ratio of the Aid flow (current US$) of Burkina Faso in 1993 to that in 1995?
Offer a terse response. 0.78. What is the ratio of the Aid flow (current US$) of Haiti in 1993 to that in 1995?
Make the answer very short. 0.1. What is the ratio of the Aid flow (current US$) in OECD members in 1993 to that in 1996?
Give a very brief answer. 0.91. What is the ratio of the Aid flow (current US$) of South Asia in 1993 to that in 1996?
Provide a succinct answer. 1.03. What is the ratio of the Aid flow (current US$) in Burkina Faso in 1993 to that in 1996?
Make the answer very short. 0.9. What is the ratio of the Aid flow (current US$) in Haiti in 1993 to that in 1996?
Make the answer very short. 1.29. What is the ratio of the Aid flow (current US$) of OECD members in 1993 to that in 1997?
Ensure brevity in your answer.  1.12. What is the ratio of the Aid flow (current US$) in South Asia in 1993 to that in 1997?
Give a very brief answer. 1.37. What is the ratio of the Aid flow (current US$) in Burkina Faso in 1993 to that in 1997?
Ensure brevity in your answer.  0.49. What is the ratio of the Aid flow (current US$) of Haiti in 1993 to that in 1997?
Keep it short and to the point. 1.83. What is the ratio of the Aid flow (current US$) of OECD members in 1993 to that in 1998?
Offer a terse response. 1.07. What is the ratio of the Aid flow (current US$) in South Asia in 1993 to that in 1998?
Your answer should be very brief. 1.84. What is the ratio of the Aid flow (current US$) in Burkina Faso in 1993 to that in 1998?
Provide a short and direct response. 0.37. What is the ratio of the Aid flow (current US$) of Haiti in 1993 to that in 1998?
Provide a short and direct response. 0.69. What is the ratio of the Aid flow (current US$) in OECD members in 1993 to that in 1999?
Your response must be concise. 1.36. What is the ratio of the Aid flow (current US$) of South Asia in 1993 to that in 1999?
Offer a terse response. 1.84. What is the ratio of the Aid flow (current US$) in Burkina Faso in 1993 to that in 1999?
Your answer should be very brief. 1.13. What is the ratio of the Aid flow (current US$) of Haiti in 1993 to that in 1999?
Your answer should be compact. 0.49. What is the ratio of the Aid flow (current US$) of OECD members in 1993 to that in 2000?
Your response must be concise. 1.46. What is the ratio of the Aid flow (current US$) in South Asia in 1993 to that in 2000?
Make the answer very short. 1.53. What is the ratio of the Aid flow (current US$) of Burkina Faso in 1993 to that in 2000?
Your response must be concise. 0.57. What is the ratio of the Aid flow (current US$) in Haiti in 1993 to that in 2000?
Keep it short and to the point. 0.45. What is the ratio of the Aid flow (current US$) of OECD members in 1994 to that in 1995?
Your response must be concise. 1.3. What is the ratio of the Aid flow (current US$) in South Asia in 1994 to that in 1995?
Offer a terse response. 1.17. What is the ratio of the Aid flow (current US$) of Burkina Faso in 1994 to that in 1995?
Your answer should be very brief. 0.2. What is the ratio of the Aid flow (current US$) in Haiti in 1994 to that in 1995?
Ensure brevity in your answer.  0.88. What is the ratio of the Aid flow (current US$) in OECD members in 1994 to that in 1996?
Ensure brevity in your answer.  1.52. What is the ratio of the Aid flow (current US$) in South Asia in 1994 to that in 1996?
Offer a very short reply. 1.21. What is the ratio of the Aid flow (current US$) in Burkina Faso in 1994 to that in 1996?
Make the answer very short. 0.23. What is the ratio of the Aid flow (current US$) in Haiti in 1994 to that in 1996?
Provide a succinct answer. 11.18. What is the ratio of the Aid flow (current US$) of OECD members in 1994 to that in 1997?
Your answer should be very brief. 1.86. What is the ratio of the Aid flow (current US$) in South Asia in 1994 to that in 1997?
Make the answer very short. 1.61. What is the ratio of the Aid flow (current US$) in Burkina Faso in 1994 to that in 1997?
Ensure brevity in your answer.  0.12. What is the ratio of the Aid flow (current US$) in Haiti in 1994 to that in 1997?
Provide a succinct answer. 15.83. What is the ratio of the Aid flow (current US$) in OECD members in 1994 to that in 1998?
Your answer should be very brief. 1.78. What is the ratio of the Aid flow (current US$) in South Asia in 1994 to that in 1998?
Keep it short and to the point. 2.16. What is the ratio of the Aid flow (current US$) in Burkina Faso in 1994 to that in 1998?
Ensure brevity in your answer.  0.09. What is the ratio of the Aid flow (current US$) in Haiti in 1994 to that in 1998?
Provide a short and direct response. 5.94. What is the ratio of the Aid flow (current US$) of OECD members in 1994 to that in 1999?
Offer a terse response. 2.26. What is the ratio of the Aid flow (current US$) in South Asia in 1994 to that in 1999?
Make the answer very short. 2.17. What is the ratio of the Aid flow (current US$) of Burkina Faso in 1994 to that in 1999?
Make the answer very short. 0.29. What is the ratio of the Aid flow (current US$) in Haiti in 1994 to that in 1999?
Provide a short and direct response. 4.22. What is the ratio of the Aid flow (current US$) of OECD members in 1994 to that in 2000?
Provide a succinct answer. 2.43. What is the ratio of the Aid flow (current US$) in South Asia in 1994 to that in 2000?
Offer a terse response. 1.8. What is the ratio of the Aid flow (current US$) in Burkina Faso in 1994 to that in 2000?
Your response must be concise. 0.15. What is the ratio of the Aid flow (current US$) of Haiti in 1994 to that in 2000?
Your answer should be very brief. 3.88. What is the ratio of the Aid flow (current US$) in OECD members in 1995 to that in 1996?
Your response must be concise. 1.16. What is the ratio of the Aid flow (current US$) in South Asia in 1995 to that in 1996?
Make the answer very short. 1.04. What is the ratio of the Aid flow (current US$) in Burkina Faso in 1995 to that in 1996?
Ensure brevity in your answer.  1.15. What is the ratio of the Aid flow (current US$) of Haiti in 1995 to that in 1996?
Make the answer very short. 12.71. What is the ratio of the Aid flow (current US$) in OECD members in 1995 to that in 1997?
Offer a terse response. 1.43. What is the ratio of the Aid flow (current US$) in South Asia in 1995 to that in 1997?
Keep it short and to the point. 1.37. What is the ratio of the Aid flow (current US$) in Burkina Faso in 1995 to that in 1997?
Ensure brevity in your answer.  0.63. What is the ratio of the Aid flow (current US$) in OECD members in 1995 to that in 1998?
Offer a very short reply. 1.37. What is the ratio of the Aid flow (current US$) of South Asia in 1995 to that in 1998?
Give a very brief answer. 1.85. What is the ratio of the Aid flow (current US$) of Burkina Faso in 1995 to that in 1998?
Your answer should be very brief. 0.47. What is the ratio of the Aid flow (current US$) in Haiti in 1995 to that in 1998?
Ensure brevity in your answer.  6.75. What is the ratio of the Aid flow (current US$) of OECD members in 1995 to that in 1999?
Provide a short and direct response. 1.73. What is the ratio of the Aid flow (current US$) in South Asia in 1995 to that in 1999?
Offer a terse response. 1.85. What is the ratio of the Aid flow (current US$) of Burkina Faso in 1995 to that in 1999?
Offer a terse response. 1.44. What is the ratio of the Aid flow (current US$) of OECD members in 1995 to that in 2000?
Provide a short and direct response. 1.86. What is the ratio of the Aid flow (current US$) of South Asia in 1995 to that in 2000?
Give a very brief answer. 1.54. What is the ratio of the Aid flow (current US$) in Burkina Faso in 1995 to that in 2000?
Your response must be concise. 0.73. What is the ratio of the Aid flow (current US$) of Haiti in 1995 to that in 2000?
Your response must be concise. 4.41. What is the ratio of the Aid flow (current US$) in OECD members in 1996 to that in 1997?
Offer a terse response. 1.23. What is the ratio of the Aid flow (current US$) of South Asia in 1996 to that in 1997?
Make the answer very short. 1.32. What is the ratio of the Aid flow (current US$) in Burkina Faso in 1996 to that in 1997?
Make the answer very short. 0.55. What is the ratio of the Aid flow (current US$) in Haiti in 1996 to that in 1997?
Your response must be concise. 1.42. What is the ratio of the Aid flow (current US$) of OECD members in 1996 to that in 1998?
Your answer should be very brief. 1.17. What is the ratio of the Aid flow (current US$) of South Asia in 1996 to that in 1998?
Keep it short and to the point. 1.78. What is the ratio of the Aid flow (current US$) of Burkina Faso in 1996 to that in 1998?
Your response must be concise. 0.41. What is the ratio of the Aid flow (current US$) in Haiti in 1996 to that in 1998?
Offer a terse response. 0.53. What is the ratio of the Aid flow (current US$) of OECD members in 1996 to that in 1999?
Your answer should be compact. 1.49. What is the ratio of the Aid flow (current US$) in South Asia in 1996 to that in 1999?
Make the answer very short. 1.79. What is the ratio of the Aid flow (current US$) in Burkina Faso in 1996 to that in 1999?
Make the answer very short. 1.25. What is the ratio of the Aid flow (current US$) of Haiti in 1996 to that in 1999?
Provide a short and direct response. 0.38. What is the ratio of the Aid flow (current US$) of OECD members in 1996 to that in 2000?
Offer a very short reply. 1.6. What is the ratio of the Aid flow (current US$) in South Asia in 1996 to that in 2000?
Make the answer very short. 1.49. What is the ratio of the Aid flow (current US$) in Burkina Faso in 1996 to that in 2000?
Give a very brief answer. 0.64. What is the ratio of the Aid flow (current US$) in Haiti in 1996 to that in 2000?
Provide a succinct answer. 0.35. What is the ratio of the Aid flow (current US$) of OECD members in 1997 to that in 1998?
Offer a terse response. 0.96. What is the ratio of the Aid flow (current US$) in South Asia in 1997 to that in 1998?
Your answer should be compact. 1.35. What is the ratio of the Aid flow (current US$) of Burkina Faso in 1997 to that in 1998?
Your response must be concise. 0.75. What is the ratio of the Aid flow (current US$) in OECD members in 1997 to that in 1999?
Provide a short and direct response. 1.22. What is the ratio of the Aid flow (current US$) in South Asia in 1997 to that in 1999?
Provide a short and direct response. 1.35. What is the ratio of the Aid flow (current US$) of Burkina Faso in 1997 to that in 1999?
Provide a succinct answer. 2.29. What is the ratio of the Aid flow (current US$) of Haiti in 1997 to that in 1999?
Give a very brief answer. 0.27. What is the ratio of the Aid flow (current US$) in OECD members in 1997 to that in 2000?
Your answer should be compact. 1.31. What is the ratio of the Aid flow (current US$) in South Asia in 1997 to that in 2000?
Your answer should be very brief. 1.12. What is the ratio of the Aid flow (current US$) of Burkina Faso in 1997 to that in 2000?
Ensure brevity in your answer.  1.16. What is the ratio of the Aid flow (current US$) of Haiti in 1997 to that in 2000?
Keep it short and to the point. 0.24. What is the ratio of the Aid flow (current US$) in OECD members in 1998 to that in 1999?
Offer a very short reply. 1.27. What is the ratio of the Aid flow (current US$) of Burkina Faso in 1998 to that in 1999?
Your answer should be very brief. 3.06. What is the ratio of the Aid flow (current US$) of Haiti in 1998 to that in 1999?
Keep it short and to the point. 0.71. What is the ratio of the Aid flow (current US$) in OECD members in 1998 to that in 2000?
Give a very brief answer. 1.36. What is the ratio of the Aid flow (current US$) of South Asia in 1998 to that in 2000?
Your answer should be very brief. 0.83. What is the ratio of the Aid flow (current US$) in Burkina Faso in 1998 to that in 2000?
Offer a very short reply. 1.56. What is the ratio of the Aid flow (current US$) of Haiti in 1998 to that in 2000?
Keep it short and to the point. 0.65. What is the ratio of the Aid flow (current US$) in OECD members in 1999 to that in 2000?
Your answer should be compact. 1.07. What is the ratio of the Aid flow (current US$) in South Asia in 1999 to that in 2000?
Offer a very short reply. 0.83. What is the ratio of the Aid flow (current US$) of Burkina Faso in 1999 to that in 2000?
Your answer should be compact. 0.51. What is the ratio of the Aid flow (current US$) of Haiti in 1999 to that in 2000?
Offer a terse response. 0.92. What is the difference between the highest and the second highest Aid flow (current US$) in OECD members?
Your answer should be very brief. 9.07e+06. What is the difference between the highest and the second highest Aid flow (current US$) in South Asia?
Offer a terse response. 2.04e+07. What is the difference between the highest and the second highest Aid flow (current US$) in Haiti?
Provide a succinct answer. 2.60e+05. What is the difference between the highest and the lowest Aid flow (current US$) of OECD members?
Provide a succinct answer. 2.28e+07. What is the difference between the highest and the lowest Aid flow (current US$) in South Asia?
Your response must be concise. 7.61e+07. What is the difference between the highest and the lowest Aid flow (current US$) in Burkina Faso?
Keep it short and to the point. 1.75e+06. What is the difference between the highest and the lowest Aid flow (current US$) in Haiti?
Offer a very short reply. 2.04e+06. 